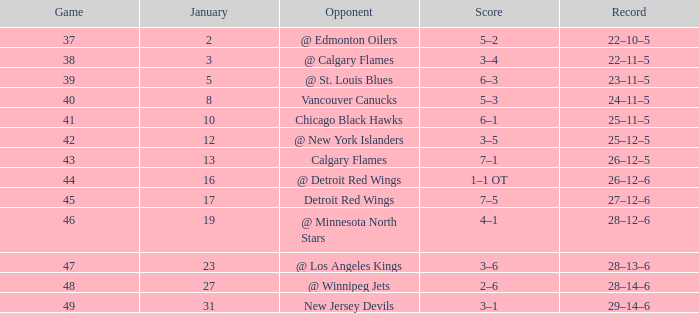On which points is the score 4-1? 62.0. 